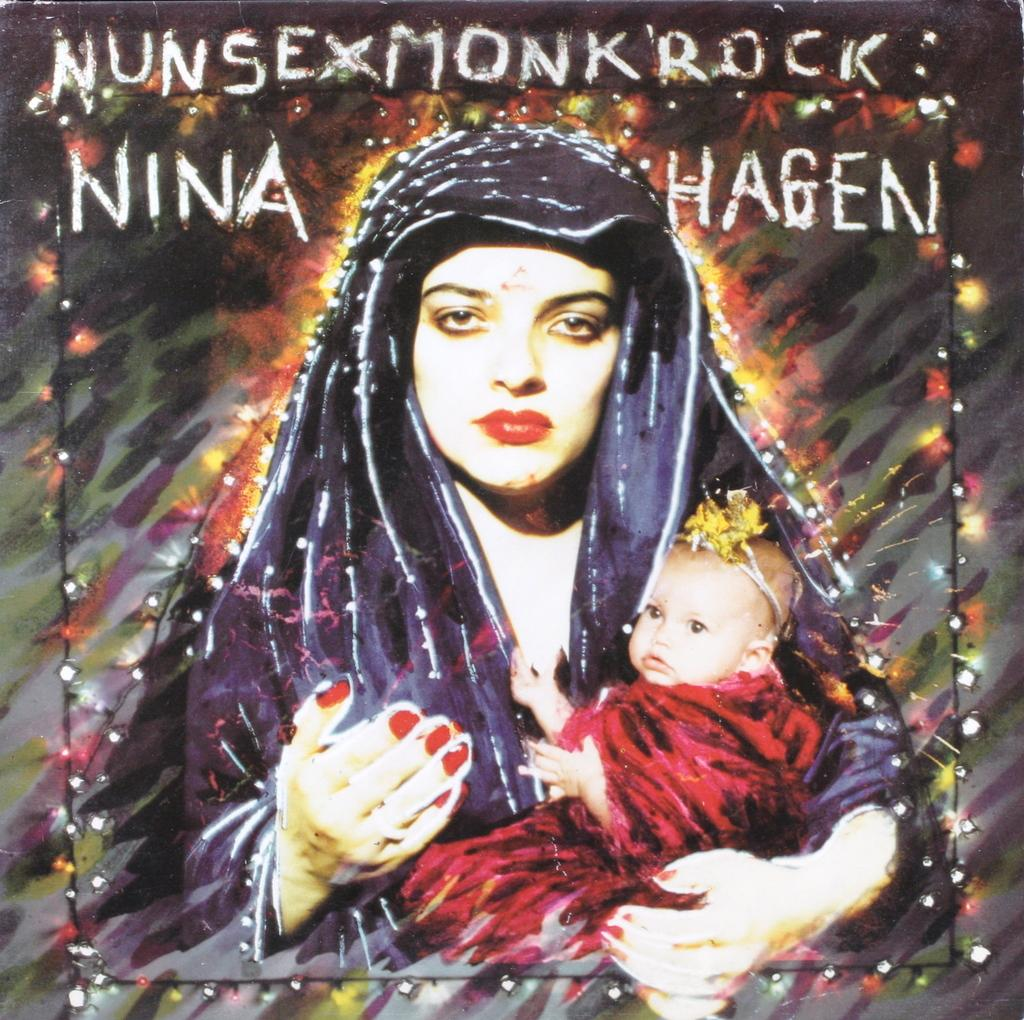What is depicted in the painting in the image? There is a painting of a woman and a baby in the image. What else can be seen in the image besides the painting? There is text and lights visible in the image. What type of religious ceremony is taking place in the image? There is no indication of a religious ceremony in the image; it features a painting of a woman and a baby, text, and lights. How many boys are present in the image? There is no boy present in the image; it only features a painting of a woman and a baby. 